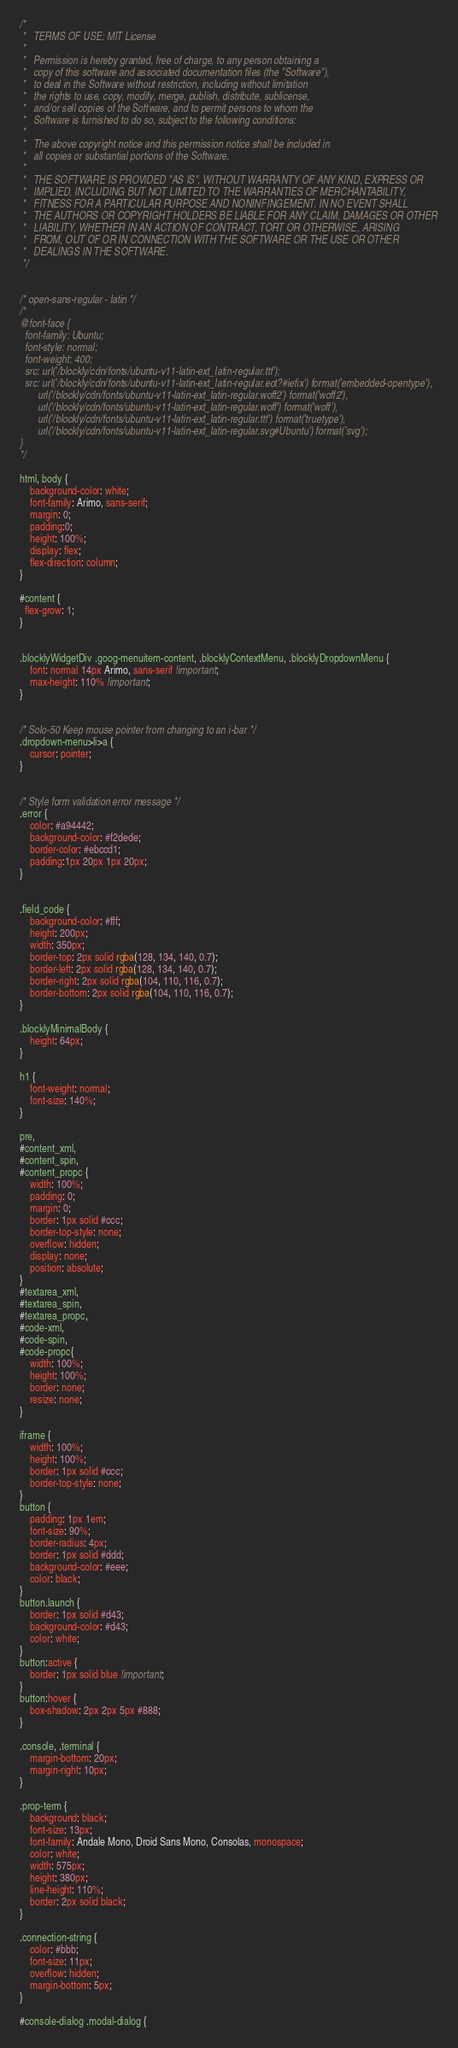<code> <loc_0><loc_0><loc_500><loc_500><_CSS_>/*
 *   TERMS OF USE: MIT License
 *
 *   Permission is hereby granted, free of charge, to any person obtaining a
 *   copy of this software and associated documentation files (the "Software"),
 *   to deal in the Software without restriction, including without limitation
 *   the rights to use, copy, modify, merge, publish, distribute, sublicense,
 *   and/or sell copies of the Software, and to permit persons to whom the
 *   Software is furnished to do so, subject to the following conditions:
 *
 *   The above copyright notice and this permission notice shall be included in
 *   all copies or substantial portions of the Software.
 *
 *   THE SOFTWARE IS PROVIDED "AS IS", WITHOUT WARRANTY OF ANY KIND, EXPRESS OR
 *   IMPLIED, INCLUDING BUT NOT LIMITED TO THE WARRANTIES OF MERCHANTABILITY,
 *   FITNESS FOR A PARTICULAR PURPOSE AND NONINFINGEMENT. IN NO EVENT SHALL
 *   THE AUTHORS OR COPYRIGHT HOLDERS BE LIABLE FOR ANY CLAIM, DAMAGES OR OTHER
 *   LIABILITY, WHETHER IN AN ACTION OF CONTRACT, TORT OR OTHERWISE, ARISING
 *   FROM, OUT OF OR IN CONNECTION WITH THE SOFTWARE OR THE USE OR OTHER
 *   DEALINGS IN THE SOFTWARE.
 */


/* open-sans-regular - latin */
/*
@font-face {
  font-family: Ubuntu;
  font-style: normal;
  font-weight: 400;
  src: url('/blockly/cdn/fonts/ubuntu-v11-latin-ext_latin-regular.ttf');
  src: url('/blockly/cdn/fonts/ubuntu-v11-latin-ext_latin-regular.eot?#iefix') format('embedded-opentype'),
       url('/blockly/cdn/fonts/ubuntu-v11-latin-ext_latin-regular.woff2') format('woff2'),
       url('/blockly/cdn/fonts/ubuntu-v11-latin-ext_latin-regular.woff') format('woff'),
       url('/blockly/cdn/fonts/ubuntu-v11-latin-ext_latin-regular.ttf') format('truetype'),
       url('/blockly/cdn/fonts/ubuntu-v11-latin-ext_latin-regular.svg#Ubuntu') format('svg');
}
*/

html, body {
    background-color: white;
    font-family: Arimo, sans-serif;
    margin: 0;
    padding:0;
    height: 100%;
    display: flex;
    flex-direction: column;
}

#content {
  flex-grow: 1;
}


.blocklyWidgetDiv .goog-menuitem-content, .blocklyContextMenu, .blocklyDropdownMenu {
    font: normal 14px Arimo, sans-serif !important;
    max-height: 110% !important;
}


/* Solo-50 Keep mouse pointer from changing to an i-bar */
.dropdown-menu>li>a {
    cursor: pointer;
}


/* Style form validation error message */
.error {
    color: #a94442;
    background-color: #f2dede;
    border-color: #ebccd1;
    padding:1px 20px 1px 20px;
}


.field_code {
    background-color: #fff;
    height: 200px;
    width: 350px;
    border-top: 2px solid rgba(128, 134, 140, 0.7);
    border-left: 2px solid rgba(128, 134, 140, 0.7);
    border-right: 2px solid rgba(104, 110, 116, 0.7);
    border-bottom: 2px solid rgba(104, 110, 116, 0.7);
}

.blocklyMinimalBody {
    height: 64px;
}

h1 {
    font-weight: normal;
    font-size: 140%;
}

pre,
#content_xml,
#content_spin,
#content_propc {
    width: 100%;
    padding: 0;
    margin: 0;
    border: 1px solid #ccc;
    border-top-style: none;
    overflow: hidden;
    display: none;
    position: absolute;
}
#textarea_xml,
#textarea_spin,
#textarea_propc,
#code-xml,
#code-spin,
#code-propc{
    width: 100%;
    height: 100%;
    border: none;
    resize: none;
}

iframe {
    width: 100%;
    height: 100%;
    border: 1px solid #ccc;
    border-top-style: none;
}
button {
    padding: 1px 1em;
    font-size: 90%;
    border-radius: 4px;
    border: 1px solid #ddd;
    background-color: #eee;
    color: black;
}
button.launch {
    border: 1px solid #d43;
    background-color: #d43;
    color: white;
}
button:active {
    border: 1px solid blue !important;
}
button:hover {
    box-shadow: 2px 2px 5px #888;
}

.console, .terminal {
    margin-bottom: 20px;
    margin-right: 10px;
}

.prop-term {
    background: black;
    font-size: 13px;
    font-family: Andale Mono, Droid Sans Mono, Consolas, monospace;
    color: white;
    width: 575px;
    height: 380px;
    line-height: 110%;
    border: 2px solid black;
}

.connection-string {
    color: #bbb;
    font-size: 11px;
    overflow: hidden;
    margin-bottom: 5px;
}

#console-dialog .modal-dialog {</code> 